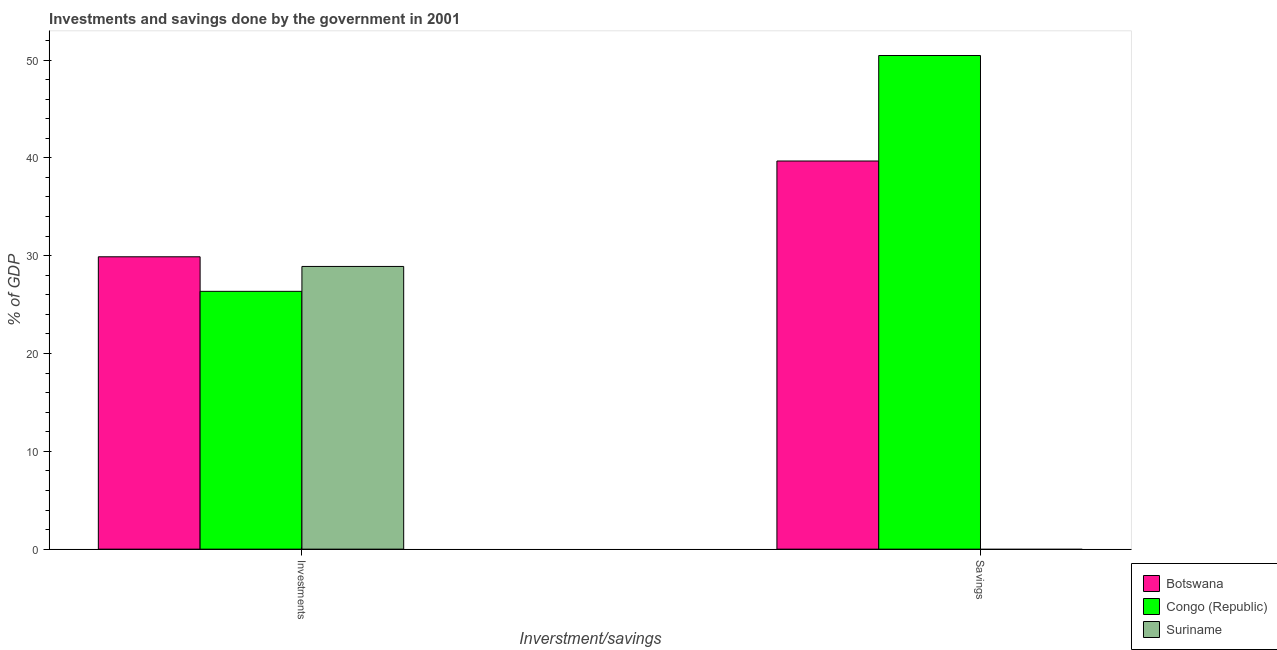How many different coloured bars are there?
Make the answer very short. 3. Are the number of bars per tick equal to the number of legend labels?
Offer a terse response. No. Are the number of bars on each tick of the X-axis equal?
Ensure brevity in your answer.  No. How many bars are there on the 1st tick from the left?
Offer a very short reply. 3. What is the label of the 2nd group of bars from the left?
Provide a succinct answer. Savings. What is the investments of government in Suriname?
Ensure brevity in your answer.  28.9. Across all countries, what is the maximum investments of government?
Offer a very short reply. 29.89. In which country was the investments of government maximum?
Your response must be concise. Botswana. What is the total savings of government in the graph?
Ensure brevity in your answer.  90.14. What is the difference between the savings of government in Botswana and that in Congo (Republic)?
Make the answer very short. -10.79. What is the difference between the investments of government in Suriname and the savings of government in Congo (Republic)?
Provide a succinct answer. -21.56. What is the average investments of government per country?
Provide a succinct answer. 28.38. What is the difference between the investments of government and savings of government in Congo (Republic)?
Your answer should be very brief. -24.11. What is the ratio of the investments of government in Suriname to that in Congo (Republic)?
Your answer should be very brief. 1.1. Are all the bars in the graph horizontal?
Make the answer very short. No. Are the values on the major ticks of Y-axis written in scientific E-notation?
Your answer should be compact. No. Does the graph contain any zero values?
Your answer should be very brief. Yes. Where does the legend appear in the graph?
Give a very brief answer. Bottom right. How many legend labels are there?
Your answer should be very brief. 3. What is the title of the graph?
Ensure brevity in your answer.  Investments and savings done by the government in 2001. What is the label or title of the X-axis?
Your answer should be compact. Inverstment/savings. What is the label or title of the Y-axis?
Your answer should be compact. % of GDP. What is the % of GDP of Botswana in Investments?
Offer a very short reply. 29.89. What is the % of GDP of Congo (Republic) in Investments?
Offer a terse response. 26.36. What is the % of GDP in Suriname in Investments?
Your response must be concise. 28.9. What is the % of GDP of Botswana in Savings?
Offer a terse response. 39.68. What is the % of GDP in Congo (Republic) in Savings?
Provide a succinct answer. 50.46. What is the % of GDP of Suriname in Savings?
Provide a succinct answer. 0. Across all Inverstment/savings, what is the maximum % of GDP of Botswana?
Your answer should be compact. 39.68. Across all Inverstment/savings, what is the maximum % of GDP in Congo (Republic)?
Provide a short and direct response. 50.46. Across all Inverstment/savings, what is the maximum % of GDP of Suriname?
Offer a terse response. 28.9. Across all Inverstment/savings, what is the minimum % of GDP in Botswana?
Make the answer very short. 29.89. Across all Inverstment/savings, what is the minimum % of GDP of Congo (Republic)?
Offer a very short reply. 26.36. Across all Inverstment/savings, what is the minimum % of GDP in Suriname?
Offer a very short reply. 0. What is the total % of GDP in Botswana in the graph?
Your answer should be very brief. 69.57. What is the total % of GDP in Congo (Republic) in the graph?
Your response must be concise. 76.82. What is the total % of GDP of Suriname in the graph?
Your response must be concise. 28.9. What is the difference between the % of GDP in Botswana in Investments and that in Savings?
Provide a short and direct response. -9.79. What is the difference between the % of GDP of Congo (Republic) in Investments and that in Savings?
Ensure brevity in your answer.  -24.11. What is the difference between the % of GDP of Botswana in Investments and the % of GDP of Congo (Republic) in Savings?
Provide a short and direct response. -20.58. What is the average % of GDP in Botswana per Inverstment/savings?
Provide a short and direct response. 34.78. What is the average % of GDP in Congo (Republic) per Inverstment/savings?
Offer a very short reply. 38.41. What is the average % of GDP in Suriname per Inverstment/savings?
Provide a succinct answer. 14.45. What is the difference between the % of GDP in Botswana and % of GDP in Congo (Republic) in Investments?
Offer a very short reply. 3.53. What is the difference between the % of GDP in Botswana and % of GDP in Suriname in Investments?
Offer a terse response. 0.99. What is the difference between the % of GDP in Congo (Republic) and % of GDP in Suriname in Investments?
Offer a very short reply. -2.54. What is the difference between the % of GDP in Botswana and % of GDP in Congo (Republic) in Savings?
Keep it short and to the point. -10.79. What is the ratio of the % of GDP in Botswana in Investments to that in Savings?
Provide a short and direct response. 0.75. What is the ratio of the % of GDP of Congo (Republic) in Investments to that in Savings?
Your response must be concise. 0.52. What is the difference between the highest and the second highest % of GDP in Botswana?
Keep it short and to the point. 9.79. What is the difference between the highest and the second highest % of GDP in Congo (Republic)?
Give a very brief answer. 24.11. What is the difference between the highest and the lowest % of GDP of Botswana?
Keep it short and to the point. 9.79. What is the difference between the highest and the lowest % of GDP of Congo (Republic)?
Provide a succinct answer. 24.11. What is the difference between the highest and the lowest % of GDP of Suriname?
Give a very brief answer. 28.9. 